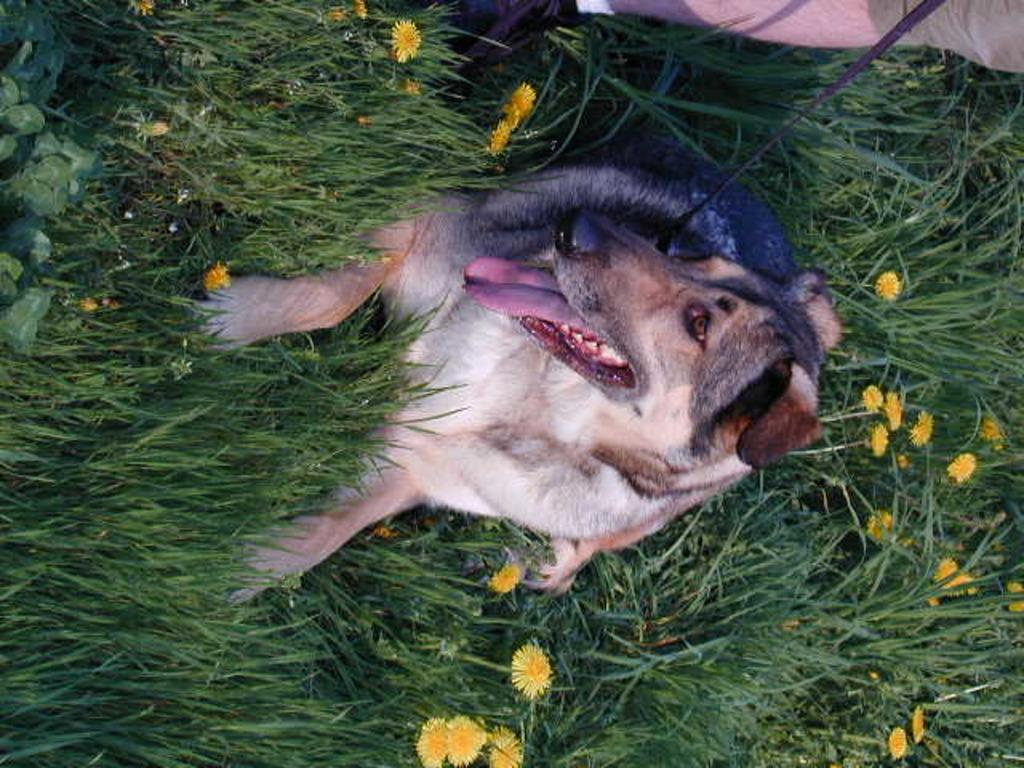What type of animal can be seen in the image? There is a dog in the image. What is attached to the dog? A thread is tied to the dog. What type of vegetation is present in the image? There are plants, grass, and flowers in the image. Whose leg is visible in the image? A person's leg is visible in the image. What is the historical significance of the dog's sister in the image? There is no mention of a dog's sister in the image, nor is there any historical context provided. 